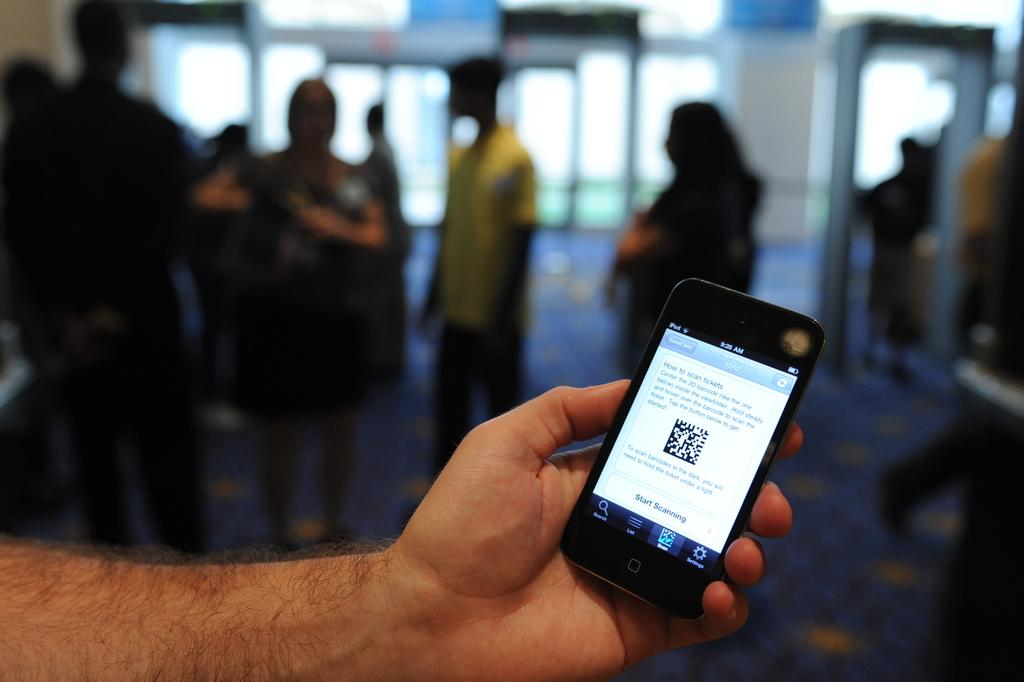What is the main subject of the image? The main subject of the image is a person's hand with a mobile. Can you describe the background of the image? The background of the image appears blurred. Are there any other people visible in the image? Yes, there are a few people visible in the background of the image. How many ducks can be seen in the image? There are no ducks present in the image. What do you believe about the ground in the image? The ground is not visible in the image, so it is not possible to make any assumptions about it. 